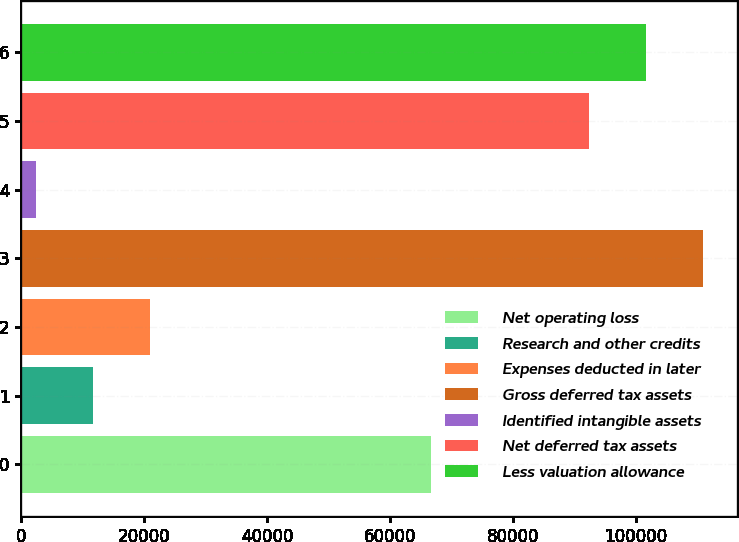Convert chart to OTSL. <chart><loc_0><loc_0><loc_500><loc_500><bar_chart><fcel>Net operating loss<fcel>Research and other credits<fcel>Expenses deducted in later<fcel>Gross deferred tax assets<fcel>Identified intangible assets<fcel>Net deferred tax assets<fcel>Less valuation allowance<nl><fcel>66597<fcel>11670.5<fcel>20910<fcel>110874<fcel>2431<fcel>92395<fcel>101634<nl></chart> 